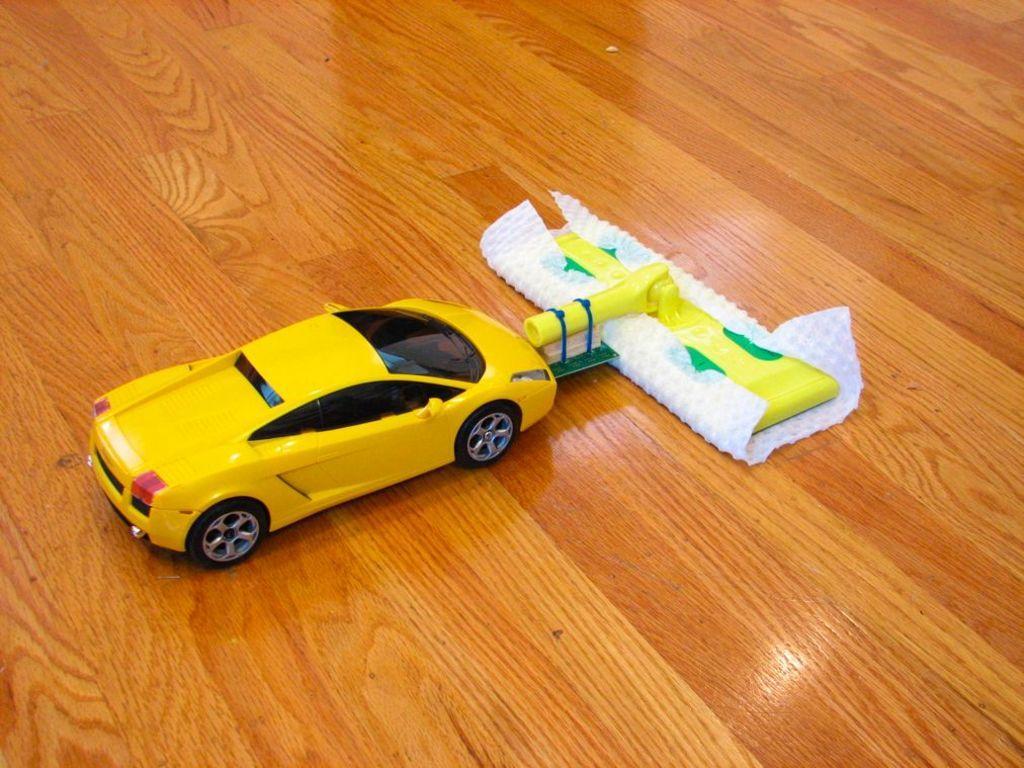Describe this image in one or two sentences. In the center of the image, we can see a toy car and an object are on the floor. 